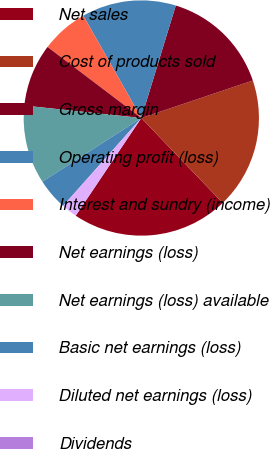Convert chart to OTSL. <chart><loc_0><loc_0><loc_500><loc_500><pie_chart><fcel>Net sales<fcel>Cost of products sold<fcel>Gross margin<fcel>Operating profit (loss)<fcel>Interest and sundry (income)<fcel>Net earnings (loss)<fcel>Net earnings (loss) available<fcel>Basic net earnings (loss)<fcel>Diluted net earnings (loss)<fcel>Dividends<nl><fcel>21.57%<fcel>18.0%<fcel>15.1%<fcel>12.94%<fcel>6.47%<fcel>8.63%<fcel>10.79%<fcel>4.32%<fcel>2.16%<fcel>0.0%<nl></chart> 